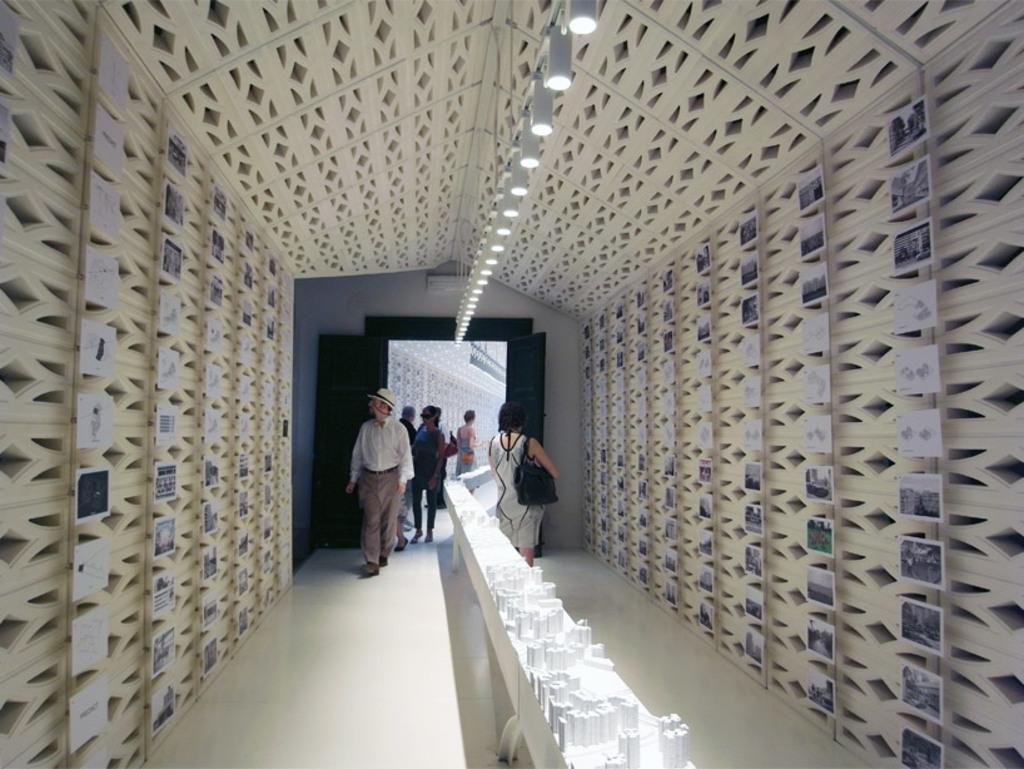Please provide a concise description of this image. In this image there is a path, on that path there are people walking, on either side of the path there is a wall to that wall there are different models at the top there are lights. 